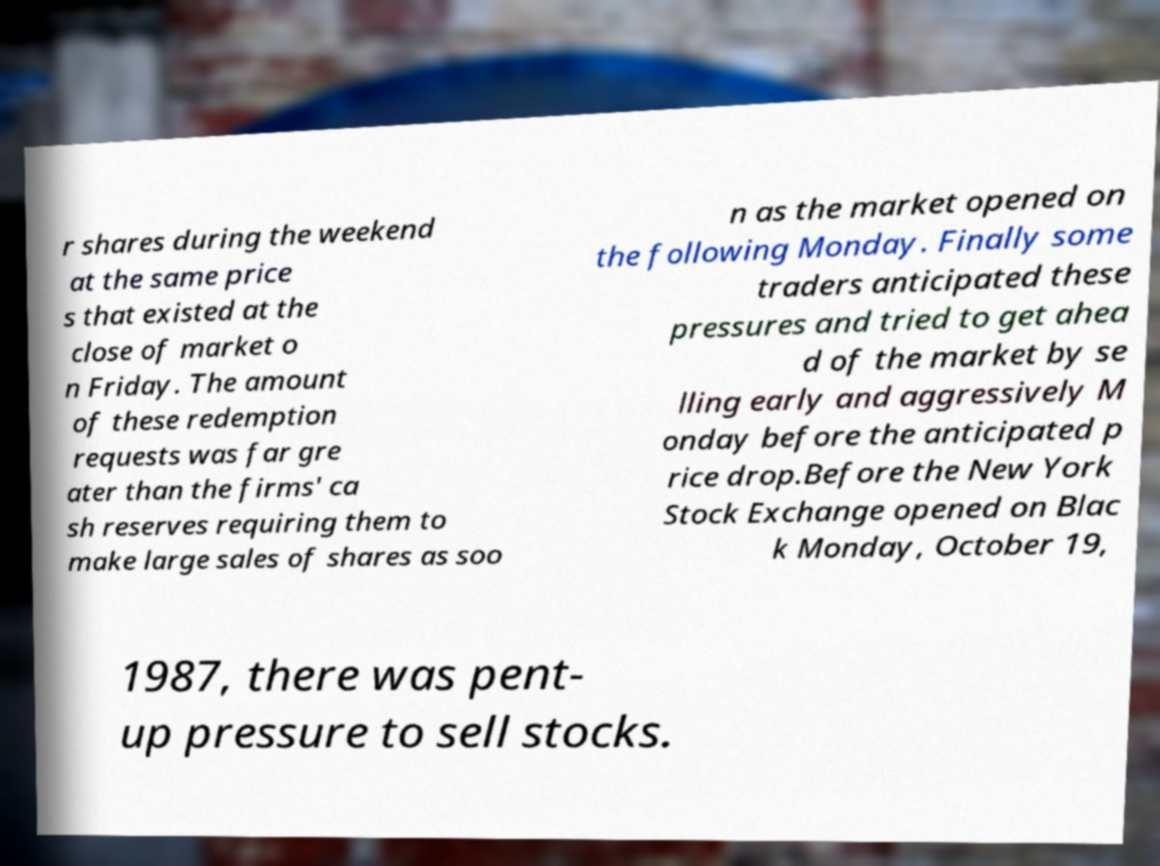Could you assist in decoding the text presented in this image and type it out clearly? r shares during the weekend at the same price s that existed at the close of market o n Friday. The amount of these redemption requests was far gre ater than the firms' ca sh reserves requiring them to make large sales of shares as soo n as the market opened on the following Monday. Finally some traders anticipated these pressures and tried to get ahea d of the market by se lling early and aggressively M onday before the anticipated p rice drop.Before the New York Stock Exchange opened on Blac k Monday, October 19, 1987, there was pent- up pressure to sell stocks. 